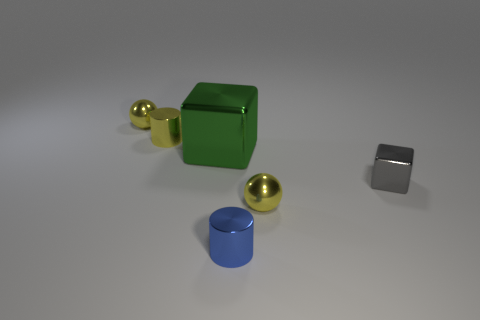There is a cylinder to the left of the cylinder in front of the metallic ball in front of the green object; what color is it?
Provide a succinct answer. Yellow. What number of yellow things are either small blocks or tiny things?
Your answer should be very brief. 3. What number of yellow metal objects have the same shape as the blue metal object?
Your answer should be compact. 1. There is a blue shiny object that is the same size as the gray object; what shape is it?
Provide a short and direct response. Cylinder. There is a tiny metal block; are there any yellow metallic spheres in front of it?
Provide a short and direct response. Yes. There is a block that is right of the tiny blue thing; are there any big metallic objects that are behind it?
Your answer should be very brief. Yes. Is the number of blue objects that are in front of the tiny blue metallic thing less than the number of yellow objects in front of the tiny yellow metallic cylinder?
Your answer should be very brief. Yes. Is there any other thing that is the same size as the green block?
Offer a terse response. No. There is a small blue object; what shape is it?
Your response must be concise. Cylinder. What material is the small cylinder behind the gray metallic cube?
Provide a succinct answer. Metal. 